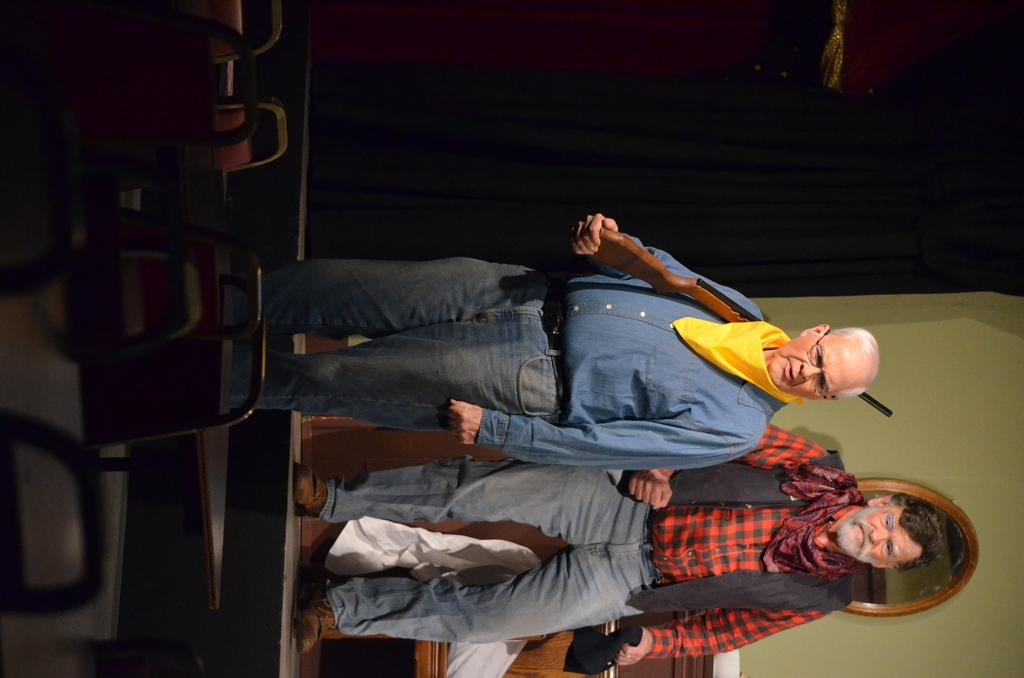How many people are present in the image? There are two persons standing in the image. Where are the persons standing? The persons are standing on the floor. What furniture can be seen in the image? There are chairs in the image. What can be seen in the background of the image? There is a wall, a mirror, and curtains in the background of the image. What type of lumber is being used to construct the chairs in the image? There is no information about the type of lumber used to construct the chairs in the image. How does the duck interact with the persons in the image? There are no ducks present in the image. 